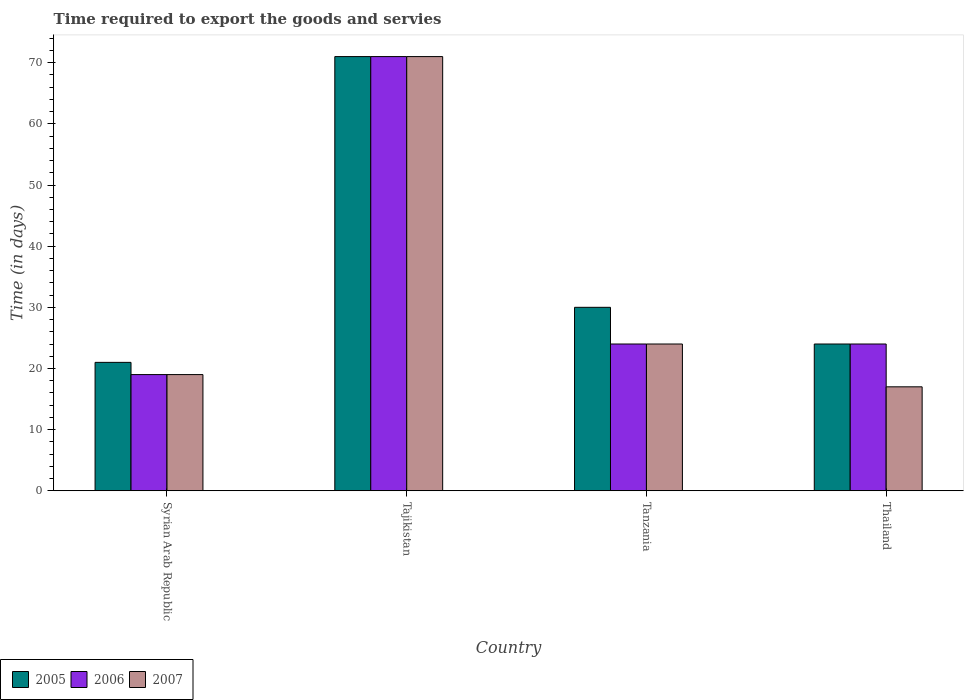How many bars are there on the 1st tick from the right?
Keep it short and to the point. 3. What is the label of the 1st group of bars from the left?
Offer a terse response. Syrian Arab Republic. Across all countries, what is the minimum number of days required to export the goods and services in 2007?
Your response must be concise. 17. In which country was the number of days required to export the goods and services in 2006 maximum?
Your answer should be compact. Tajikistan. In which country was the number of days required to export the goods and services in 2006 minimum?
Provide a succinct answer. Syrian Arab Republic. What is the total number of days required to export the goods and services in 2007 in the graph?
Ensure brevity in your answer.  131. What is the average number of days required to export the goods and services in 2006 per country?
Keep it short and to the point. 34.5. What is the difference between the number of days required to export the goods and services of/in 2006 and number of days required to export the goods and services of/in 2005 in Syrian Arab Republic?
Make the answer very short. -2. What is the ratio of the number of days required to export the goods and services in 2006 in Tanzania to that in Thailand?
Your answer should be compact. 1. Is the number of days required to export the goods and services in 2006 in Tajikistan less than that in Thailand?
Provide a succinct answer. No. How many bars are there?
Provide a succinct answer. 12. Are all the bars in the graph horizontal?
Ensure brevity in your answer.  No. How many countries are there in the graph?
Ensure brevity in your answer.  4. Are the values on the major ticks of Y-axis written in scientific E-notation?
Your answer should be very brief. No. Does the graph contain grids?
Offer a very short reply. No. What is the title of the graph?
Offer a very short reply. Time required to export the goods and servies. What is the label or title of the Y-axis?
Your response must be concise. Time (in days). What is the Time (in days) of 2005 in Syrian Arab Republic?
Provide a short and direct response. 21. What is the Time (in days) of 2006 in Syrian Arab Republic?
Your answer should be compact. 19. What is the Time (in days) in 2006 in Tajikistan?
Give a very brief answer. 71. What is the Time (in days) of 2007 in Tajikistan?
Your response must be concise. 71. What is the Time (in days) of 2006 in Tanzania?
Ensure brevity in your answer.  24. What is the Time (in days) of 2005 in Thailand?
Provide a succinct answer. 24. What is the Time (in days) of 2006 in Thailand?
Keep it short and to the point. 24. What is the Time (in days) in 2007 in Thailand?
Your answer should be compact. 17. Across all countries, what is the maximum Time (in days) of 2006?
Your answer should be very brief. 71. Across all countries, what is the minimum Time (in days) of 2005?
Keep it short and to the point. 21. Across all countries, what is the minimum Time (in days) in 2006?
Make the answer very short. 19. What is the total Time (in days) in 2005 in the graph?
Make the answer very short. 146. What is the total Time (in days) of 2006 in the graph?
Ensure brevity in your answer.  138. What is the total Time (in days) of 2007 in the graph?
Your response must be concise. 131. What is the difference between the Time (in days) in 2006 in Syrian Arab Republic and that in Tajikistan?
Ensure brevity in your answer.  -52. What is the difference between the Time (in days) of 2007 in Syrian Arab Republic and that in Tajikistan?
Your response must be concise. -52. What is the difference between the Time (in days) in 2005 in Syrian Arab Republic and that in Tanzania?
Give a very brief answer. -9. What is the difference between the Time (in days) in 2006 in Syrian Arab Republic and that in Tanzania?
Offer a very short reply. -5. What is the difference between the Time (in days) of 2005 in Syrian Arab Republic and that in Thailand?
Ensure brevity in your answer.  -3. What is the difference between the Time (in days) of 2006 in Syrian Arab Republic and that in Thailand?
Offer a very short reply. -5. What is the difference between the Time (in days) of 2007 in Syrian Arab Republic and that in Thailand?
Provide a short and direct response. 2. What is the difference between the Time (in days) in 2005 in Tajikistan and that in Thailand?
Give a very brief answer. 47. What is the difference between the Time (in days) of 2007 in Tajikistan and that in Thailand?
Your answer should be very brief. 54. What is the difference between the Time (in days) in 2007 in Tanzania and that in Thailand?
Keep it short and to the point. 7. What is the difference between the Time (in days) in 2005 in Syrian Arab Republic and the Time (in days) in 2007 in Tajikistan?
Your answer should be very brief. -50. What is the difference between the Time (in days) in 2006 in Syrian Arab Republic and the Time (in days) in 2007 in Tajikistan?
Ensure brevity in your answer.  -52. What is the difference between the Time (in days) in 2005 in Syrian Arab Republic and the Time (in days) in 2006 in Tanzania?
Offer a very short reply. -3. What is the difference between the Time (in days) of 2005 in Syrian Arab Republic and the Time (in days) of 2007 in Tanzania?
Ensure brevity in your answer.  -3. What is the difference between the Time (in days) of 2006 in Syrian Arab Republic and the Time (in days) of 2007 in Tanzania?
Keep it short and to the point. -5. What is the difference between the Time (in days) in 2006 in Syrian Arab Republic and the Time (in days) in 2007 in Thailand?
Make the answer very short. 2. What is the difference between the Time (in days) in 2006 in Tajikistan and the Time (in days) in 2007 in Tanzania?
Offer a terse response. 47. What is the difference between the Time (in days) in 2005 in Tajikistan and the Time (in days) in 2007 in Thailand?
Your answer should be compact. 54. What is the difference between the Time (in days) of 2006 in Tanzania and the Time (in days) of 2007 in Thailand?
Your response must be concise. 7. What is the average Time (in days) in 2005 per country?
Offer a very short reply. 36.5. What is the average Time (in days) in 2006 per country?
Offer a very short reply. 34.5. What is the average Time (in days) of 2007 per country?
Offer a very short reply. 32.75. What is the difference between the Time (in days) of 2005 and Time (in days) of 2006 in Syrian Arab Republic?
Provide a short and direct response. 2. What is the difference between the Time (in days) in 2006 and Time (in days) in 2007 in Syrian Arab Republic?
Offer a very short reply. 0. What is the difference between the Time (in days) in 2006 and Time (in days) in 2007 in Tajikistan?
Provide a succinct answer. 0. What is the difference between the Time (in days) in 2006 and Time (in days) in 2007 in Tanzania?
Give a very brief answer. 0. What is the difference between the Time (in days) of 2005 and Time (in days) of 2006 in Thailand?
Your response must be concise. 0. What is the difference between the Time (in days) of 2005 and Time (in days) of 2007 in Thailand?
Give a very brief answer. 7. What is the difference between the Time (in days) in 2006 and Time (in days) in 2007 in Thailand?
Offer a terse response. 7. What is the ratio of the Time (in days) in 2005 in Syrian Arab Republic to that in Tajikistan?
Your answer should be very brief. 0.3. What is the ratio of the Time (in days) in 2006 in Syrian Arab Republic to that in Tajikistan?
Keep it short and to the point. 0.27. What is the ratio of the Time (in days) of 2007 in Syrian Arab Republic to that in Tajikistan?
Your answer should be very brief. 0.27. What is the ratio of the Time (in days) in 2006 in Syrian Arab Republic to that in Tanzania?
Your answer should be compact. 0.79. What is the ratio of the Time (in days) in 2007 in Syrian Arab Republic to that in Tanzania?
Provide a short and direct response. 0.79. What is the ratio of the Time (in days) in 2006 in Syrian Arab Republic to that in Thailand?
Give a very brief answer. 0.79. What is the ratio of the Time (in days) of 2007 in Syrian Arab Republic to that in Thailand?
Offer a very short reply. 1.12. What is the ratio of the Time (in days) in 2005 in Tajikistan to that in Tanzania?
Ensure brevity in your answer.  2.37. What is the ratio of the Time (in days) of 2006 in Tajikistan to that in Tanzania?
Your answer should be very brief. 2.96. What is the ratio of the Time (in days) in 2007 in Tajikistan to that in Tanzania?
Offer a terse response. 2.96. What is the ratio of the Time (in days) in 2005 in Tajikistan to that in Thailand?
Make the answer very short. 2.96. What is the ratio of the Time (in days) in 2006 in Tajikistan to that in Thailand?
Your answer should be compact. 2.96. What is the ratio of the Time (in days) in 2007 in Tajikistan to that in Thailand?
Offer a very short reply. 4.18. What is the ratio of the Time (in days) of 2005 in Tanzania to that in Thailand?
Provide a succinct answer. 1.25. What is the ratio of the Time (in days) of 2007 in Tanzania to that in Thailand?
Give a very brief answer. 1.41. What is the difference between the highest and the second highest Time (in days) in 2005?
Provide a short and direct response. 41. What is the difference between the highest and the lowest Time (in days) of 2006?
Make the answer very short. 52. What is the difference between the highest and the lowest Time (in days) in 2007?
Offer a very short reply. 54. 